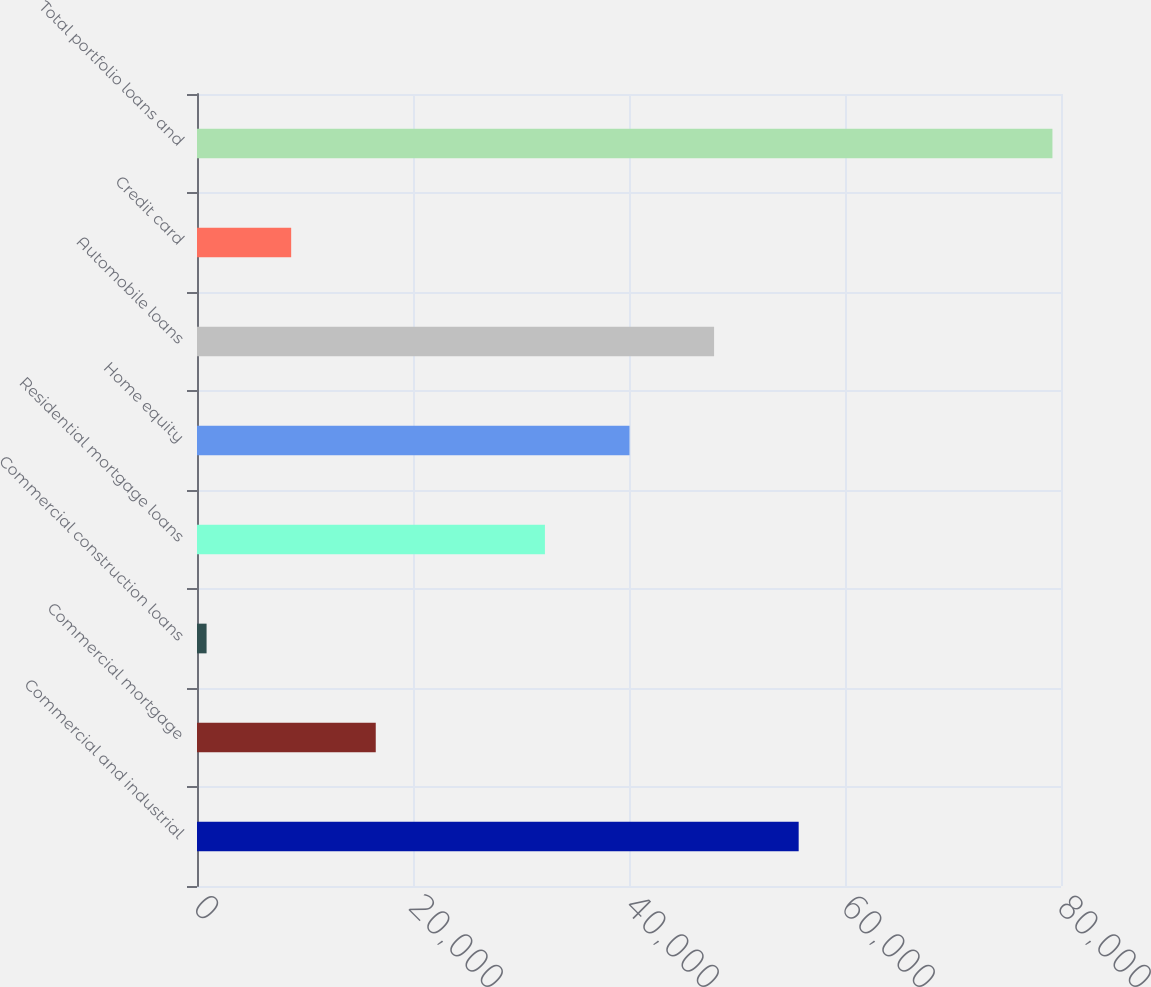Convert chart to OTSL. <chart><loc_0><loc_0><loc_500><loc_500><bar_chart><fcel>Commercial and industrial<fcel>Commercial mortgage<fcel>Commercial construction loans<fcel>Residential mortgage loans<fcel>Home equity<fcel>Automobile loans<fcel>Credit card<fcel>Total portfolio loans and<nl><fcel>55711<fcel>16551<fcel>887<fcel>32215<fcel>40047<fcel>47879<fcel>8719<fcel>79207<nl></chart> 